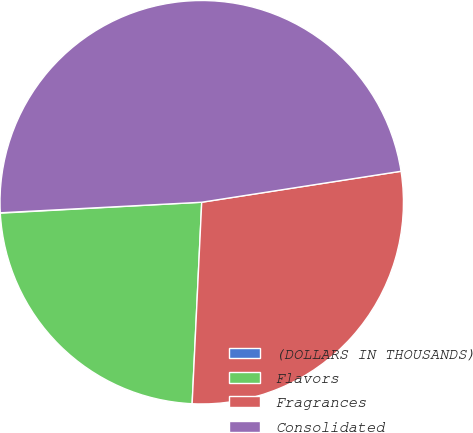Convert chart. <chart><loc_0><loc_0><loc_500><loc_500><pie_chart><fcel>(DOLLARS IN THOUSANDS)<fcel>Flavors<fcel>Fragrances<fcel>Consolidated<nl><fcel>0.03%<fcel>23.38%<fcel>28.21%<fcel>48.38%<nl></chart> 